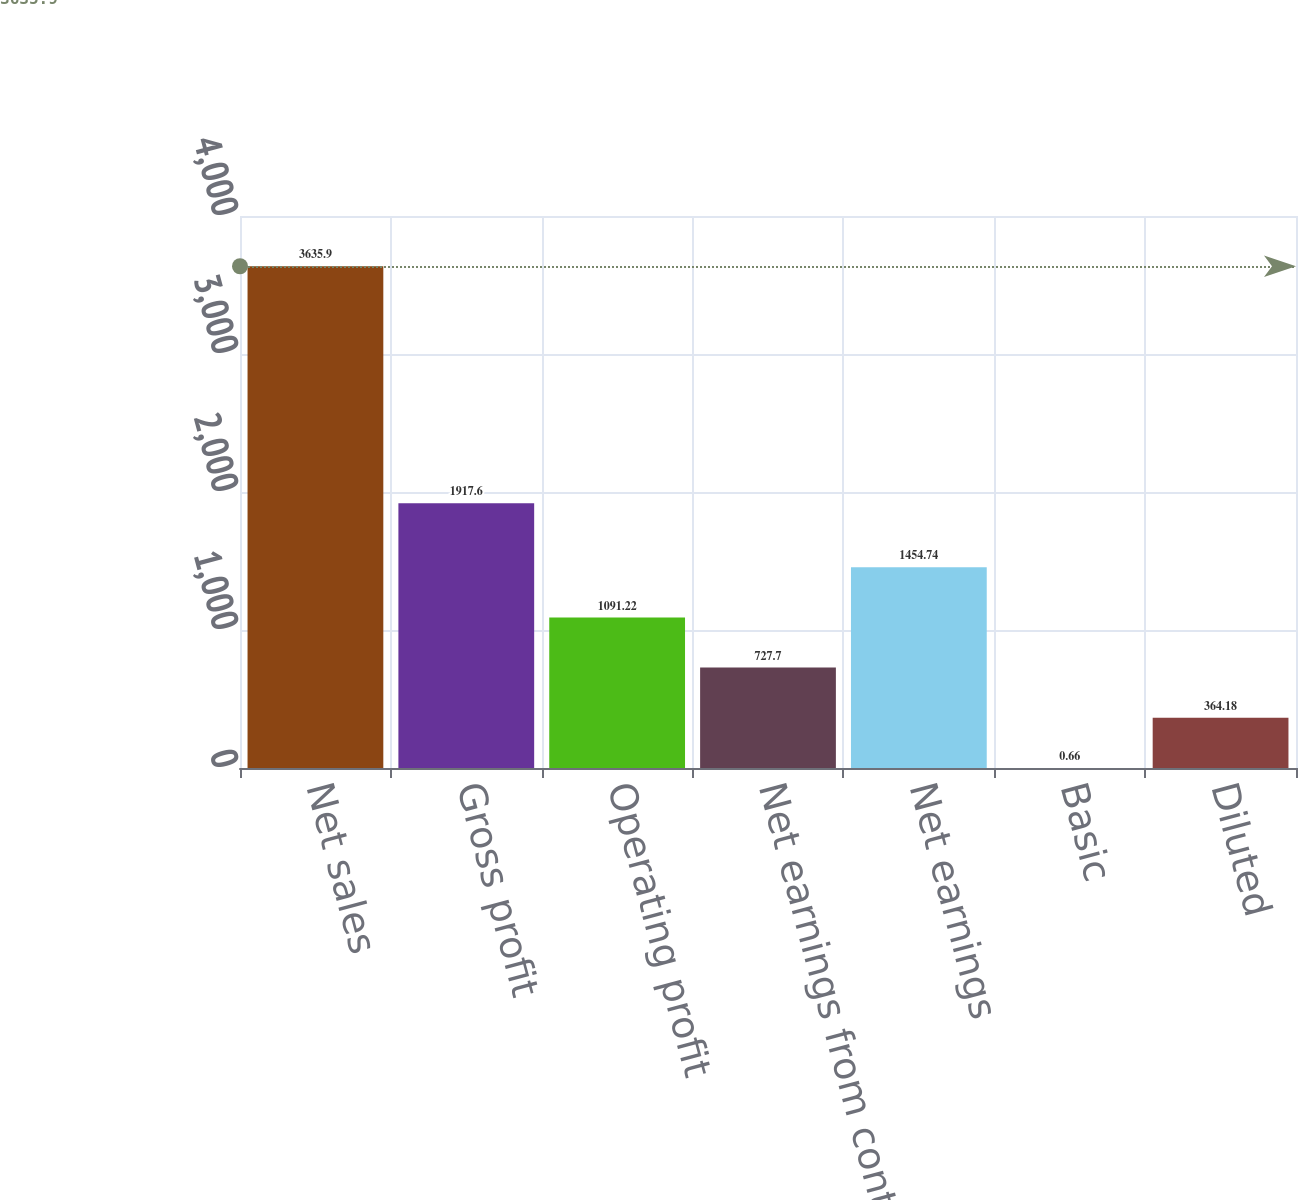Convert chart to OTSL. <chart><loc_0><loc_0><loc_500><loc_500><bar_chart><fcel>Net sales<fcel>Gross profit<fcel>Operating profit<fcel>Net earnings from continuing<fcel>Net earnings<fcel>Basic<fcel>Diluted<nl><fcel>3635.9<fcel>1917.6<fcel>1091.22<fcel>727.7<fcel>1454.74<fcel>0.66<fcel>364.18<nl></chart> 